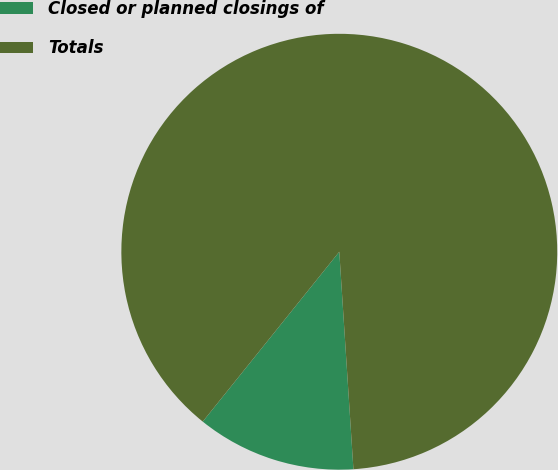<chart> <loc_0><loc_0><loc_500><loc_500><pie_chart><fcel>Closed or planned closings of<fcel>Totals<nl><fcel>11.81%<fcel>88.19%<nl></chart> 